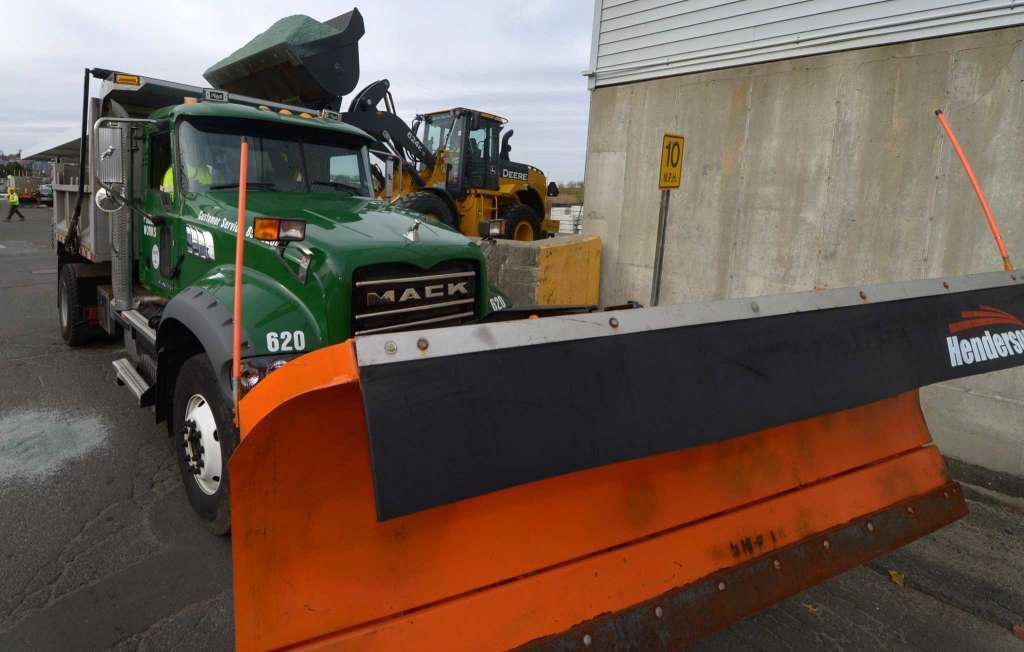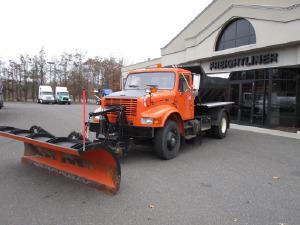The first image is the image on the left, the second image is the image on the right. For the images displayed, is the sentence "A truck in each image is equipped with a front-facing orange show blade, but neither truck is plowing snow." factually correct? Answer yes or no. Yes. 